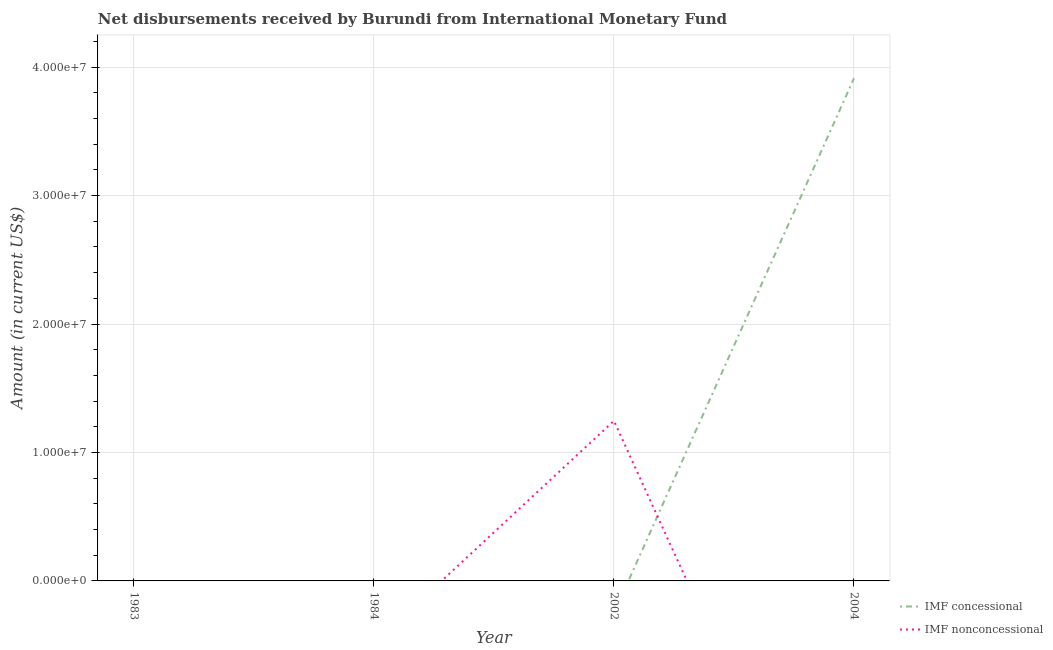Does the line corresponding to net concessional disbursements from imf intersect with the line corresponding to net non concessional disbursements from imf?
Your response must be concise. Yes. Is the number of lines equal to the number of legend labels?
Give a very brief answer. No. What is the net non concessional disbursements from imf in 1984?
Ensure brevity in your answer.  0. Across all years, what is the maximum net concessional disbursements from imf?
Your response must be concise. 3.91e+07. What is the total net non concessional disbursements from imf in the graph?
Offer a very short reply. 1.25e+07. What is the average net non concessional disbursements from imf per year?
Your response must be concise. 3.12e+06. In how many years, is the net concessional disbursements from imf greater than 40000000 US$?
Offer a terse response. 0. What is the difference between the highest and the lowest net concessional disbursements from imf?
Keep it short and to the point. 3.91e+07. Does the net non concessional disbursements from imf monotonically increase over the years?
Keep it short and to the point. No. Is the net non concessional disbursements from imf strictly greater than the net concessional disbursements from imf over the years?
Keep it short and to the point. No. How many years are there in the graph?
Offer a terse response. 4. What is the difference between two consecutive major ticks on the Y-axis?
Offer a very short reply. 1.00e+07. Are the values on the major ticks of Y-axis written in scientific E-notation?
Offer a terse response. Yes. Does the graph contain any zero values?
Provide a short and direct response. Yes. How many legend labels are there?
Your answer should be very brief. 2. What is the title of the graph?
Give a very brief answer. Net disbursements received by Burundi from International Monetary Fund. What is the Amount (in current US$) in IMF concessional in 2002?
Ensure brevity in your answer.  0. What is the Amount (in current US$) of IMF nonconcessional in 2002?
Offer a very short reply. 1.25e+07. What is the Amount (in current US$) of IMF concessional in 2004?
Keep it short and to the point. 3.91e+07. Across all years, what is the maximum Amount (in current US$) in IMF concessional?
Provide a short and direct response. 3.91e+07. Across all years, what is the maximum Amount (in current US$) of IMF nonconcessional?
Offer a terse response. 1.25e+07. Across all years, what is the minimum Amount (in current US$) in IMF nonconcessional?
Your answer should be compact. 0. What is the total Amount (in current US$) in IMF concessional in the graph?
Provide a short and direct response. 3.91e+07. What is the total Amount (in current US$) of IMF nonconcessional in the graph?
Your answer should be compact. 1.25e+07. What is the average Amount (in current US$) of IMF concessional per year?
Provide a succinct answer. 9.78e+06. What is the average Amount (in current US$) of IMF nonconcessional per year?
Your answer should be compact. 3.12e+06. What is the difference between the highest and the lowest Amount (in current US$) of IMF concessional?
Keep it short and to the point. 3.91e+07. What is the difference between the highest and the lowest Amount (in current US$) of IMF nonconcessional?
Ensure brevity in your answer.  1.25e+07. 